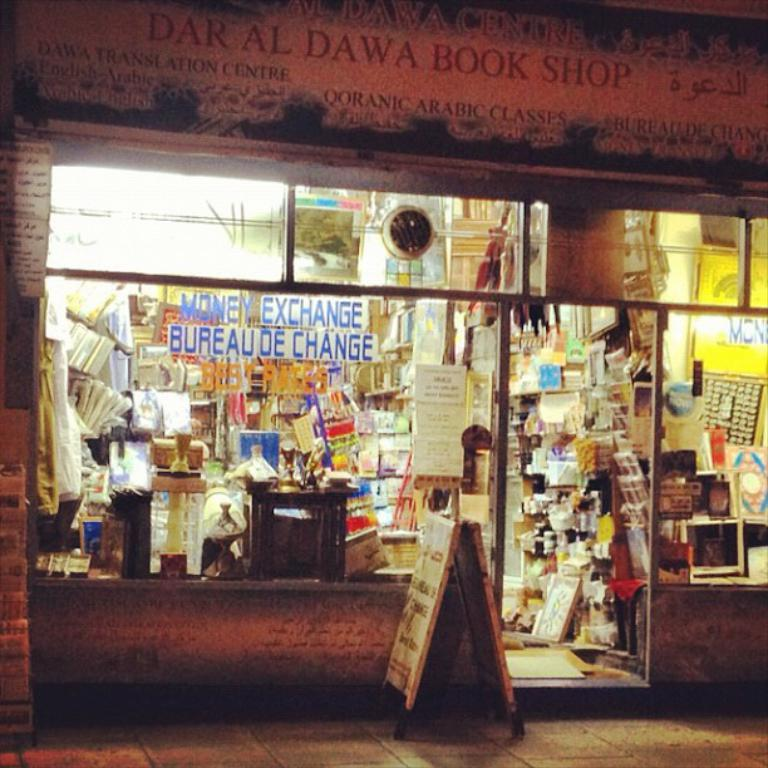<image>
Give a short and clear explanation of the subsequent image. A book store called Daral Dawa Book Shop is open on a dark street. 